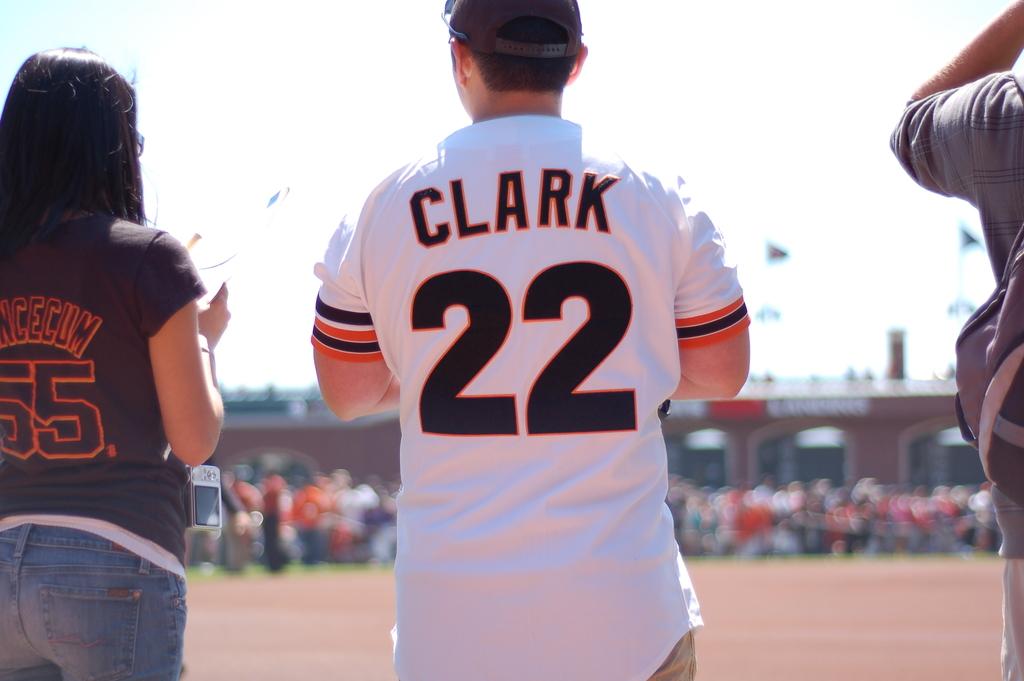What number is on the white jersey?
Your response must be concise. 22. What is the name on the white jersey?
Ensure brevity in your answer.  Clark. 